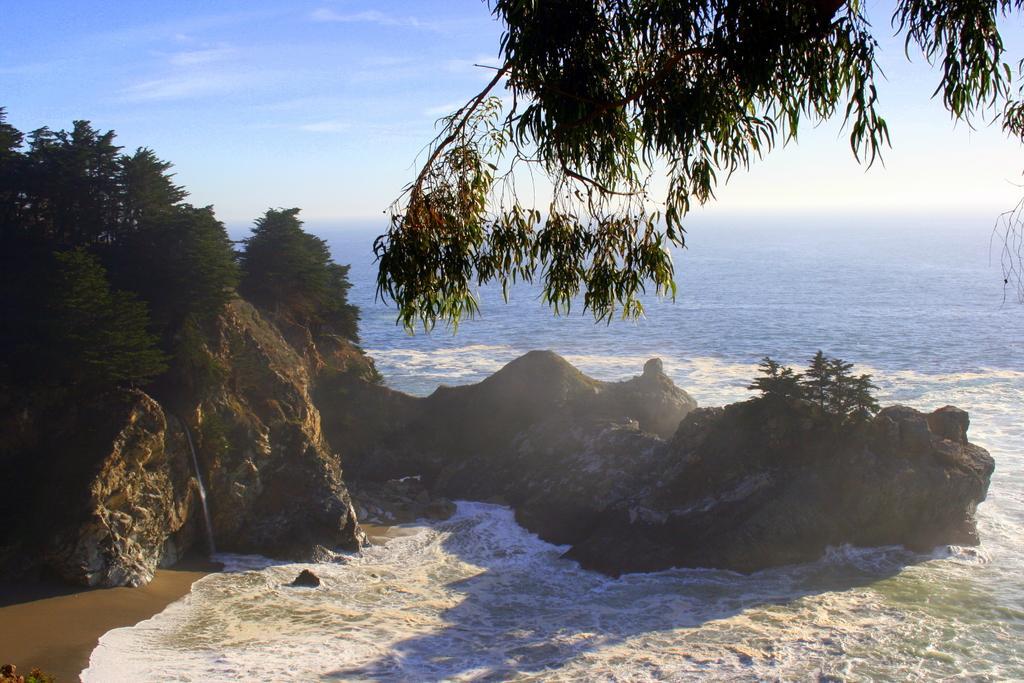Please provide a concise description of this image. In the foreground of the picture there are trees, mountain, water, sand and stems of a tree. In the middle there is a water body. In the background there is sky. 